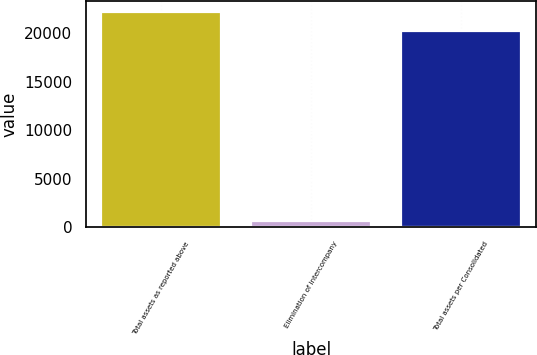Convert chart to OTSL. <chart><loc_0><loc_0><loc_500><loc_500><bar_chart><fcel>Total assets as reported above<fcel>Elimination of intercompany<fcel>Total assets per Consolidated<nl><fcel>22192.5<fcel>657<fcel>20175<nl></chart> 